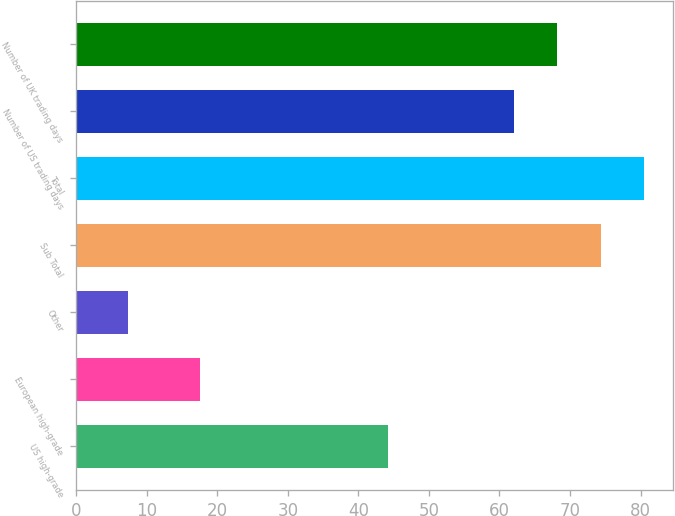<chart> <loc_0><loc_0><loc_500><loc_500><bar_chart><fcel>US high-grade<fcel>European high-grade<fcel>Other<fcel>Sub Total<fcel>Total<fcel>Number of US trading days<fcel>Number of UK trading days<nl><fcel>44.2<fcel>17.6<fcel>7.4<fcel>74.34<fcel>80.51<fcel>62<fcel>68.17<nl></chart> 